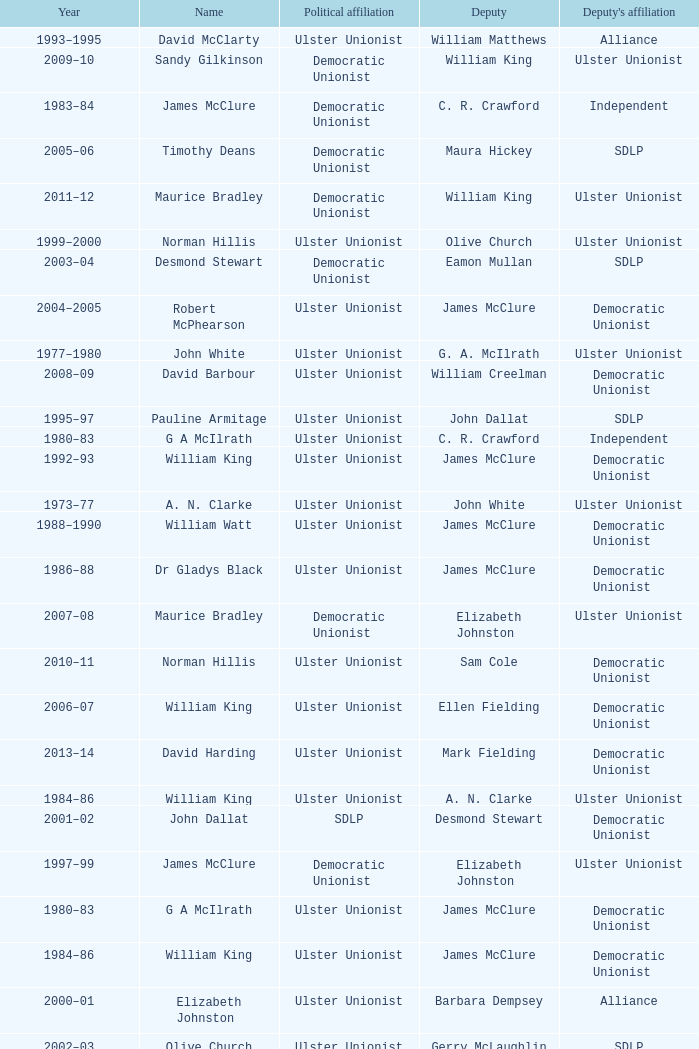What is the Political affiliation of deputy john dallat? Ulster Unionist. 